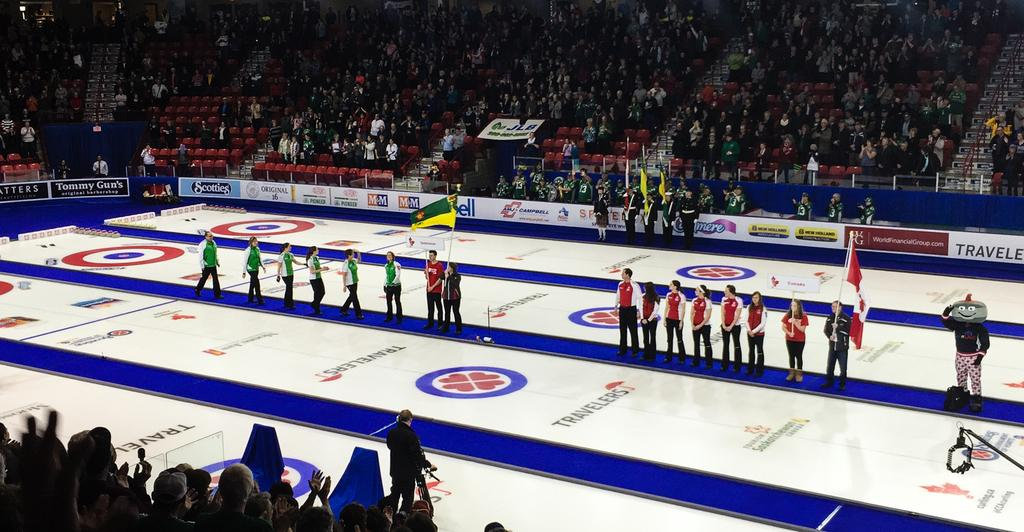<image>
Present a compact description of the photo's key features. people lined up inside of an arena with a travelers logo on the ground 